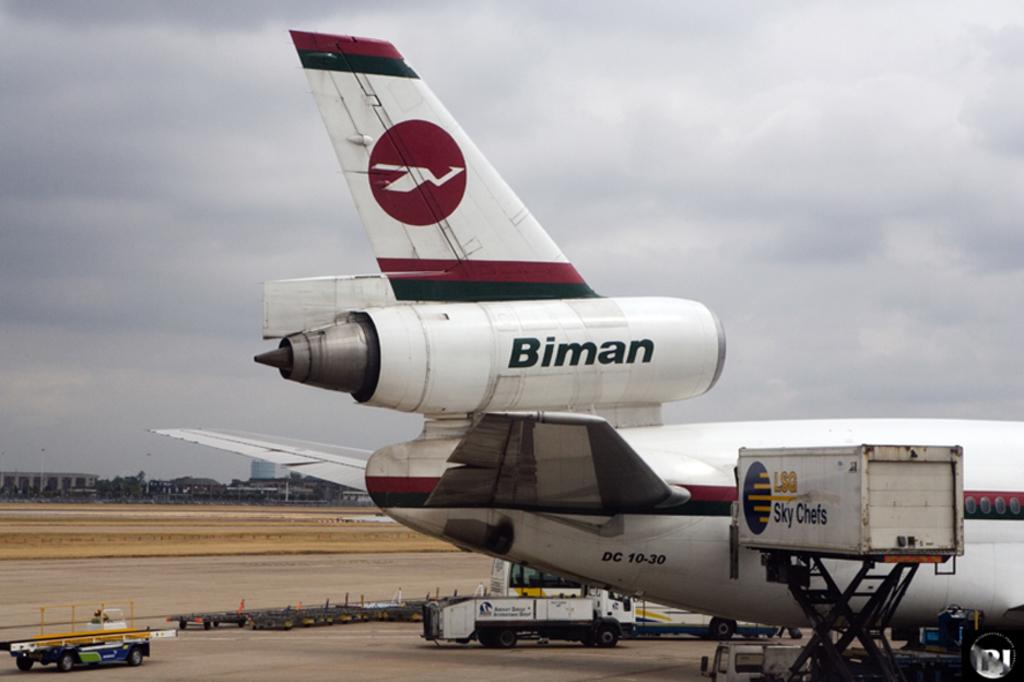<image>
Present a compact description of the photo's key features. A Biman airplane is sitting on a runway. 